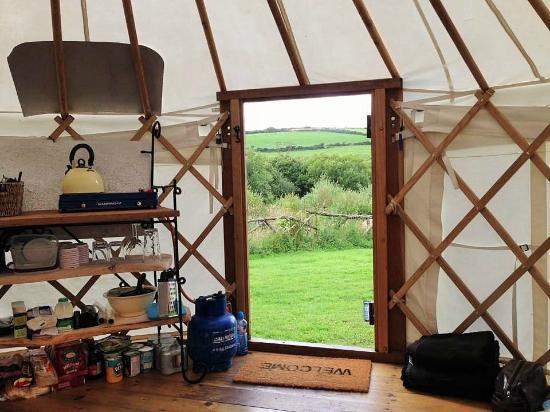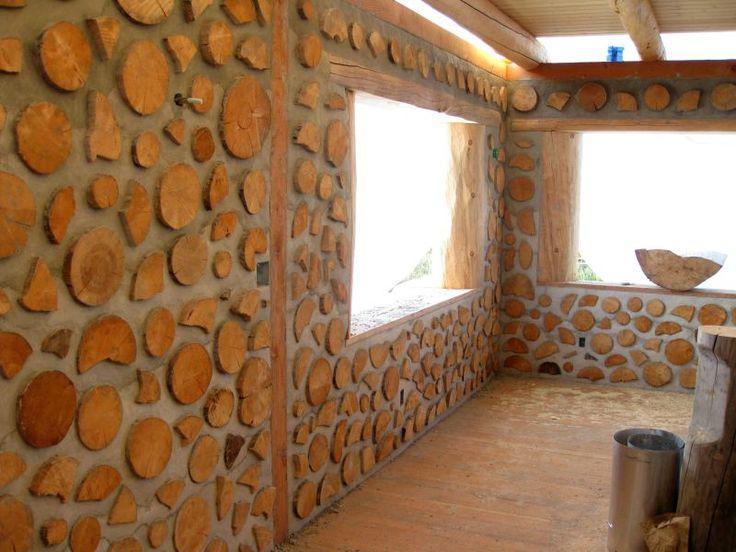The first image is the image on the left, the second image is the image on the right. Examine the images to the left and right. Is the description "In one image, a white kitchen sink is built into a wooden cabinet, and is situated in front of a window near wall shelves stocked with kitchen supplies." accurate? Answer yes or no. No. The first image is the image on the left, the second image is the image on the right. Considering the images on both sides, is "An image of a yurt's interior shows a wood slab countertop that ends with a curving corner." valid? Answer yes or no. No. 